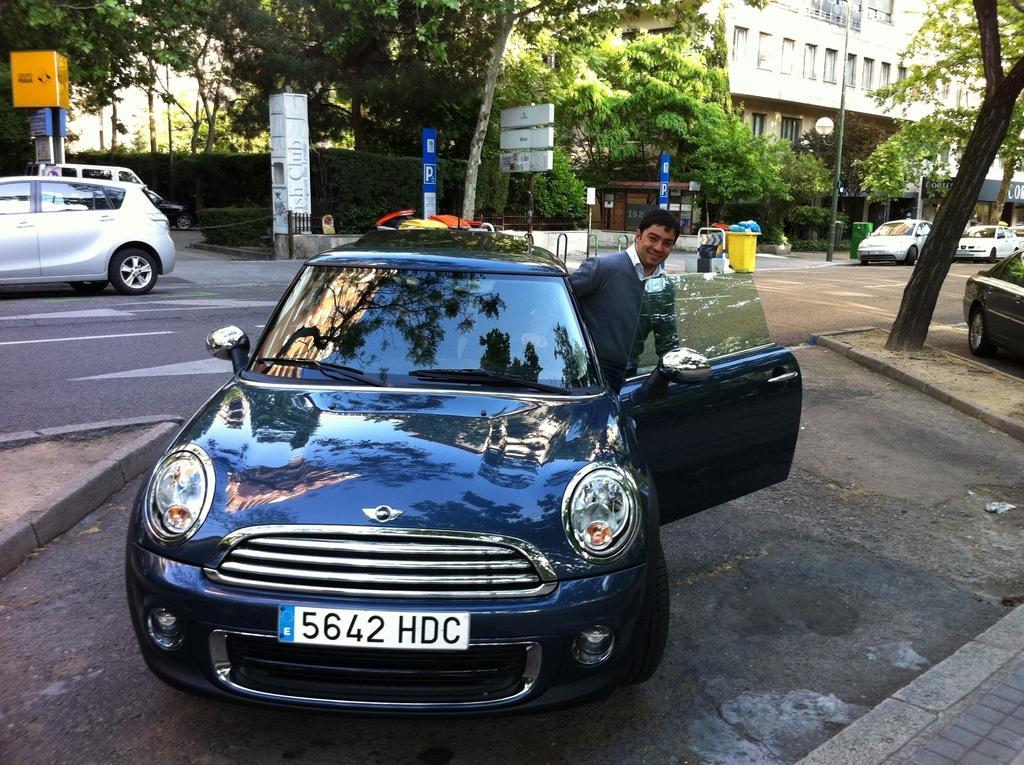Could you give a brief overview of what you see in this image? This image consists of a car in blue color. We can see a man beside the car. At the bottom, there is a road. In the background, there are trees and building. And there are many cars parked on the road. 